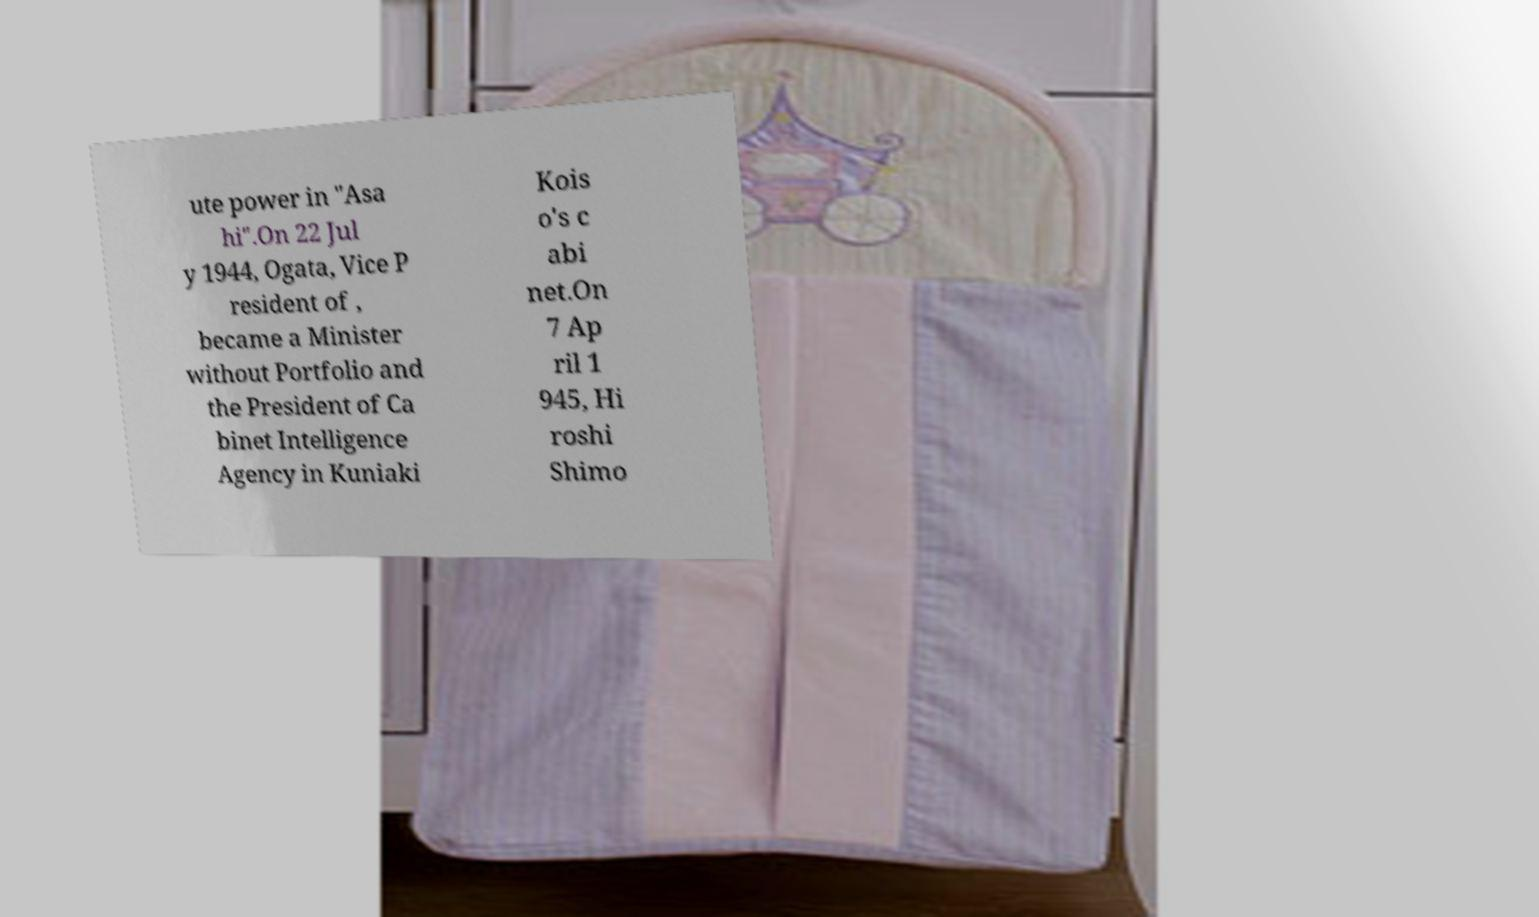Could you extract and type out the text from this image? ute power in "Asa hi".On 22 Jul y 1944, Ogata, Vice P resident of , became a Minister without Portfolio and the President of Ca binet Intelligence Agency in Kuniaki Kois o's c abi net.On 7 Ap ril 1 945, Hi roshi Shimo 